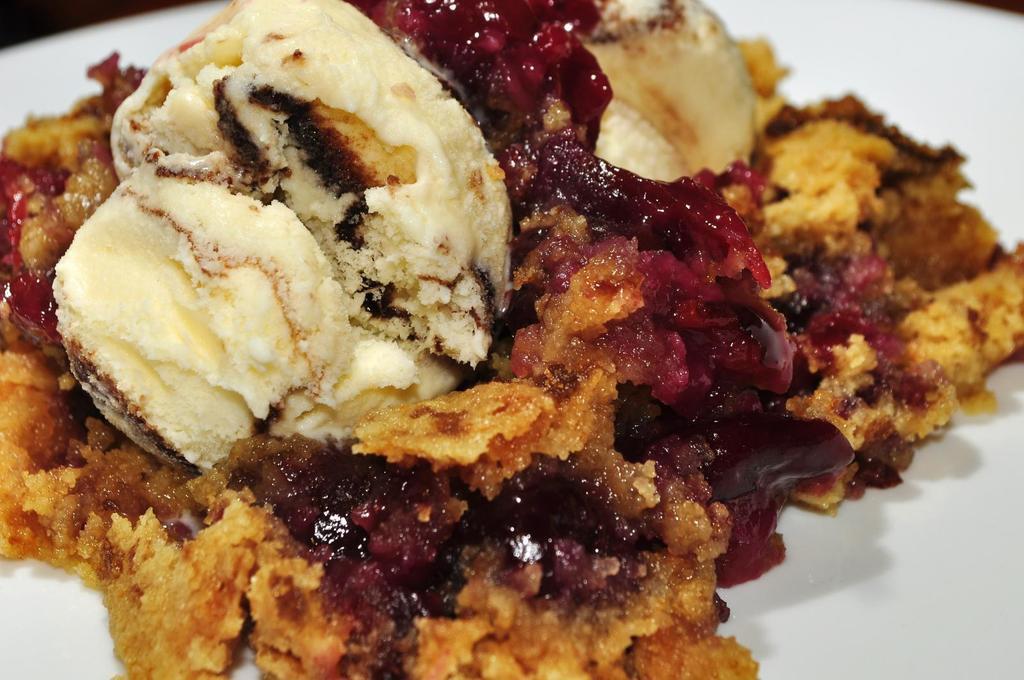Describe this image in one or two sentences. In this image I can see there is a plate. On the plate there is some food item. 